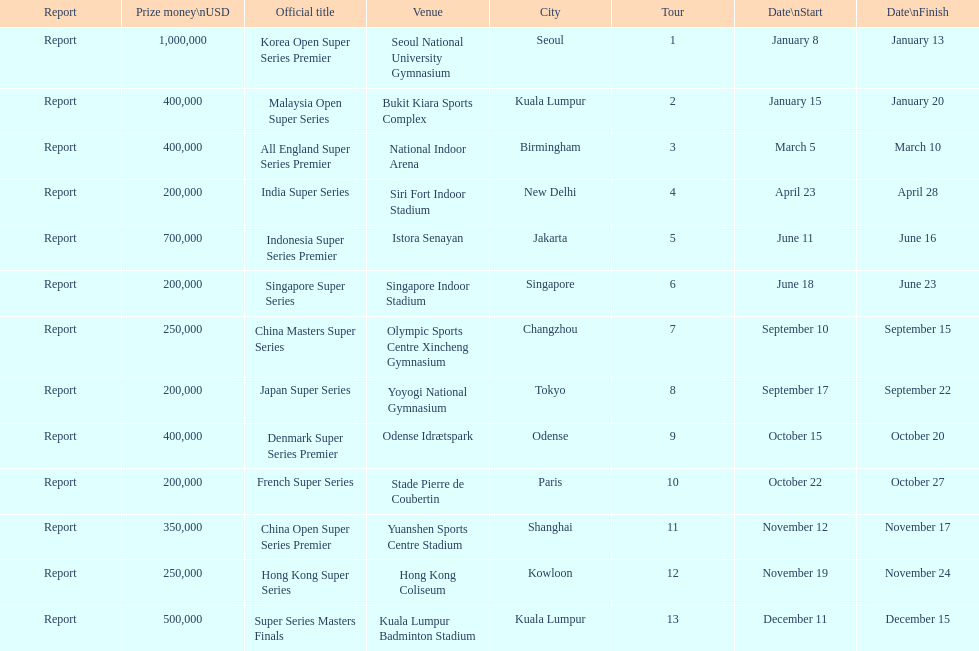Which series has the highest prize payout? Korea Open Super Series Premier. I'm looking to parse the entire table for insights. Could you assist me with that? {'header': ['Report', 'Prize money\\nUSD', 'Official title', 'Venue', 'City', 'Tour', 'Date\\nStart', 'Date\\nFinish'], 'rows': [['Report', '1,000,000', 'Korea Open Super Series Premier', 'Seoul National University Gymnasium', 'Seoul', '1', 'January 8', 'January 13'], ['Report', '400,000', 'Malaysia Open Super Series', 'Bukit Kiara Sports Complex', 'Kuala Lumpur', '2', 'January 15', 'January 20'], ['Report', '400,000', 'All England Super Series Premier', 'National Indoor Arena', 'Birmingham', '3', 'March 5', 'March 10'], ['Report', '200,000', 'India Super Series', 'Siri Fort Indoor Stadium', 'New Delhi', '4', 'April 23', 'April 28'], ['Report', '700,000', 'Indonesia Super Series Premier', 'Istora Senayan', 'Jakarta', '5', 'June 11', 'June 16'], ['Report', '200,000', 'Singapore Super Series', 'Singapore Indoor Stadium', 'Singapore', '6', 'June 18', 'June 23'], ['Report', '250,000', 'China Masters Super Series', 'Olympic Sports Centre Xincheng Gymnasium', 'Changzhou', '7', 'September 10', 'September 15'], ['Report', '200,000', 'Japan Super Series', 'Yoyogi National Gymnasium', 'Tokyo', '8', 'September 17', 'September 22'], ['Report', '400,000', 'Denmark Super Series Premier', 'Odense Idrætspark', 'Odense', '9', 'October 15', 'October 20'], ['Report', '200,000', 'French Super Series', 'Stade Pierre de Coubertin', 'Paris', '10', 'October 22', 'October 27'], ['Report', '350,000', 'China Open Super Series Premier', 'Yuanshen Sports Centre Stadium', 'Shanghai', '11', 'November 12', 'November 17'], ['Report', '250,000', 'Hong Kong Super Series', 'Hong Kong Coliseum', 'Kowloon', '12', 'November 19', 'November 24'], ['Report', '500,000', 'Super Series Masters Finals', 'Kuala Lumpur Badminton Stadium', 'Kuala Lumpur', '13', 'December 11', 'December 15']]} 